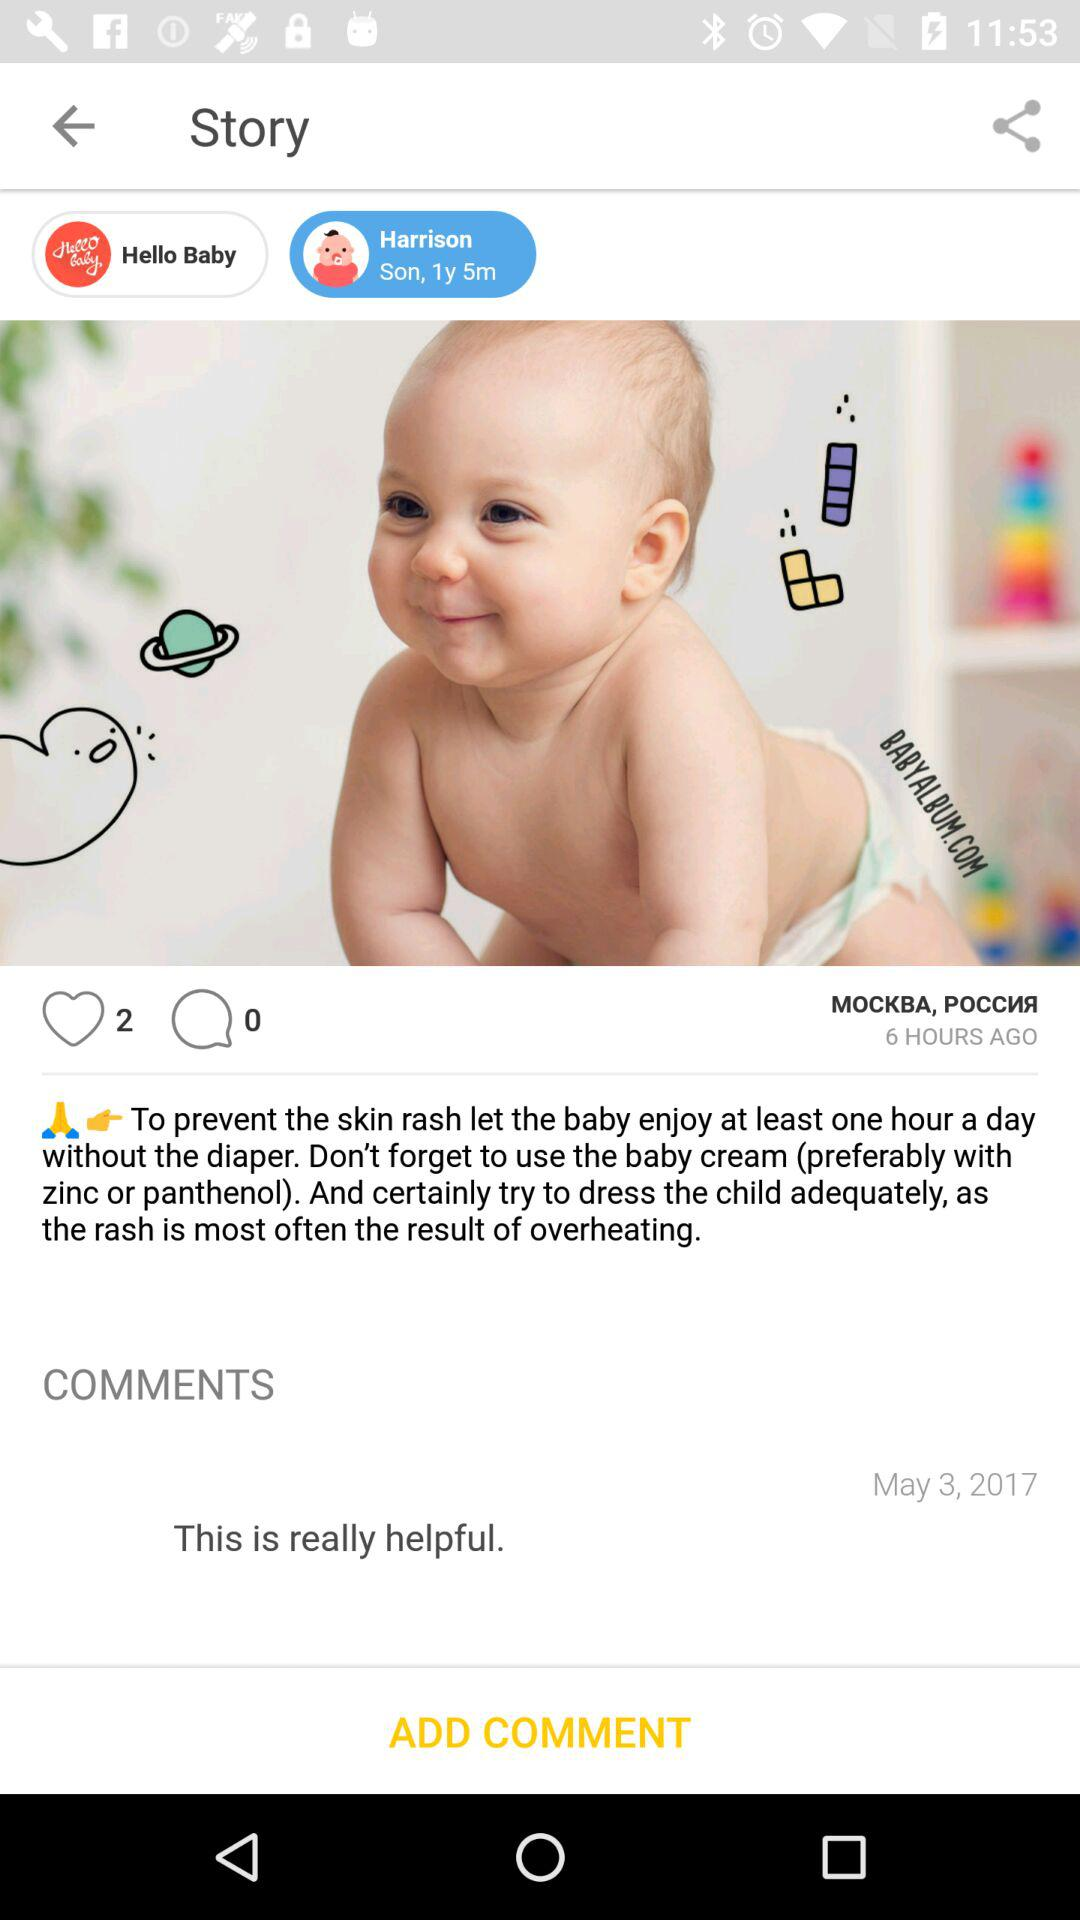How many hours ago was this post made?
Answer the question using a single word or phrase. 6 